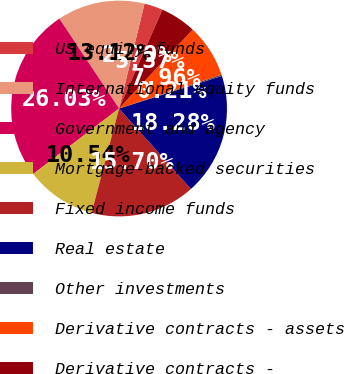<chart> <loc_0><loc_0><loc_500><loc_500><pie_chart><fcel>US equity funds<fcel>International equity funds<fcel>Government and agency<fcel>Mortgage-backed securities<fcel>Fixed income funds<fcel>Real estate<fcel>Other investments<fcel>Derivative contracts - assets<fcel>Derivative contracts -<nl><fcel>2.79%<fcel>13.12%<fcel>26.03%<fcel>10.54%<fcel>15.7%<fcel>18.28%<fcel>0.21%<fcel>7.96%<fcel>5.37%<nl></chart> 